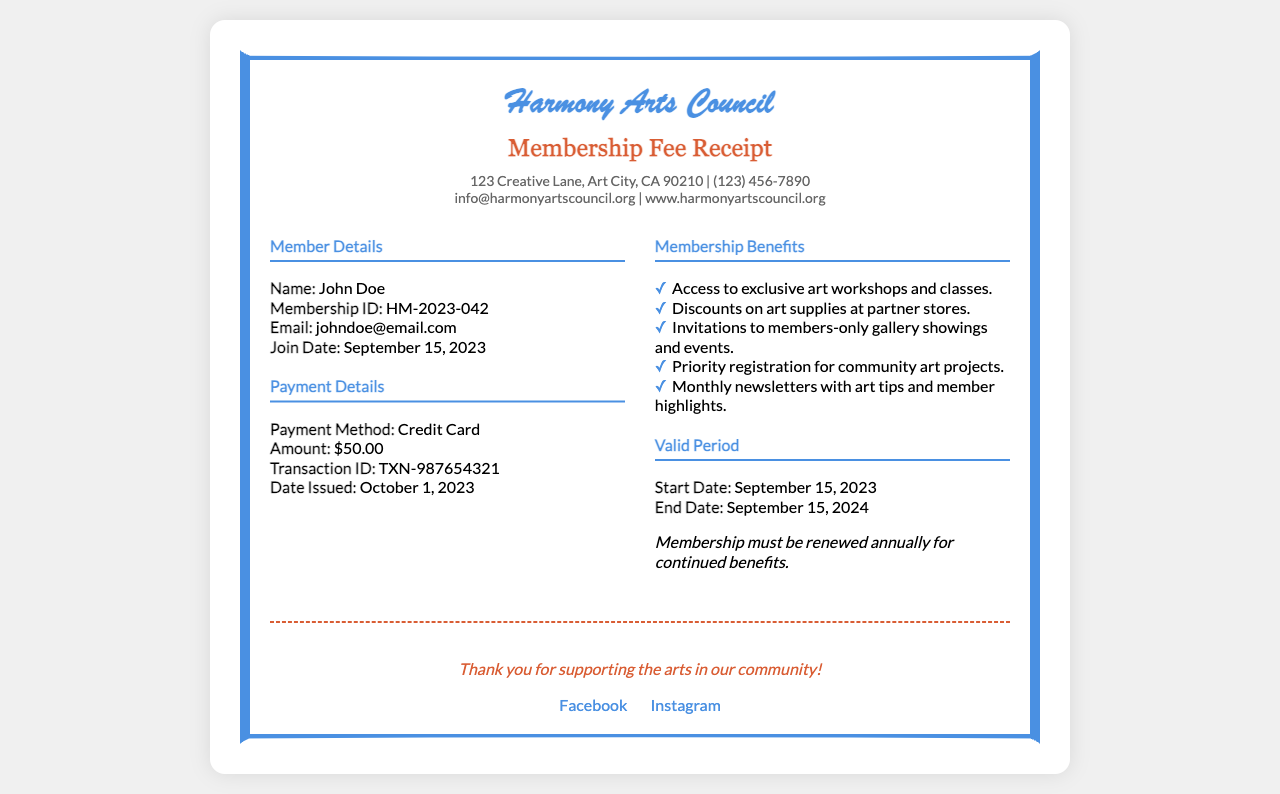what is the name of the organization? The name of the organization is displayed prominently at the top of the receipt.
Answer: Harmony Arts Council what is the membership ID? The membership ID is provided under the member details section of the receipt.
Answer: HM-2023-042 what is the amount paid for the membership? The amount paid is stated in the payment details section of the receipt.
Answer: $50.00 when does the membership start? The start date for the membership is specified in the valid period section of the receipt.
Answer: September 15, 2023 what benefits are available to members? The benefits are listed in a bulleted format under the membership benefits section of the receipt.
Answer: Access to exclusive art workshops and classes how long is the membership valid? The valid period is indicated under the valid period section, showing the end date of membership.
Answer: September 15, 2024 what method was used to pay for the membership? The payment method is mentioned in the payment details section of the receipt.
Answer: Credit Card what should members do for continued benefits? The requirement for continued benefits is stated in the valid period section of the receipt.
Answer: Renew annually what is the transaction ID? The transaction ID is found in the payment details section of the receipt.
Answer: TXN-987654321 how can members follow the organization on social media? The organization provides links to social media platforms at the bottom of the receipt.
Answer: Facebook, Instagram 